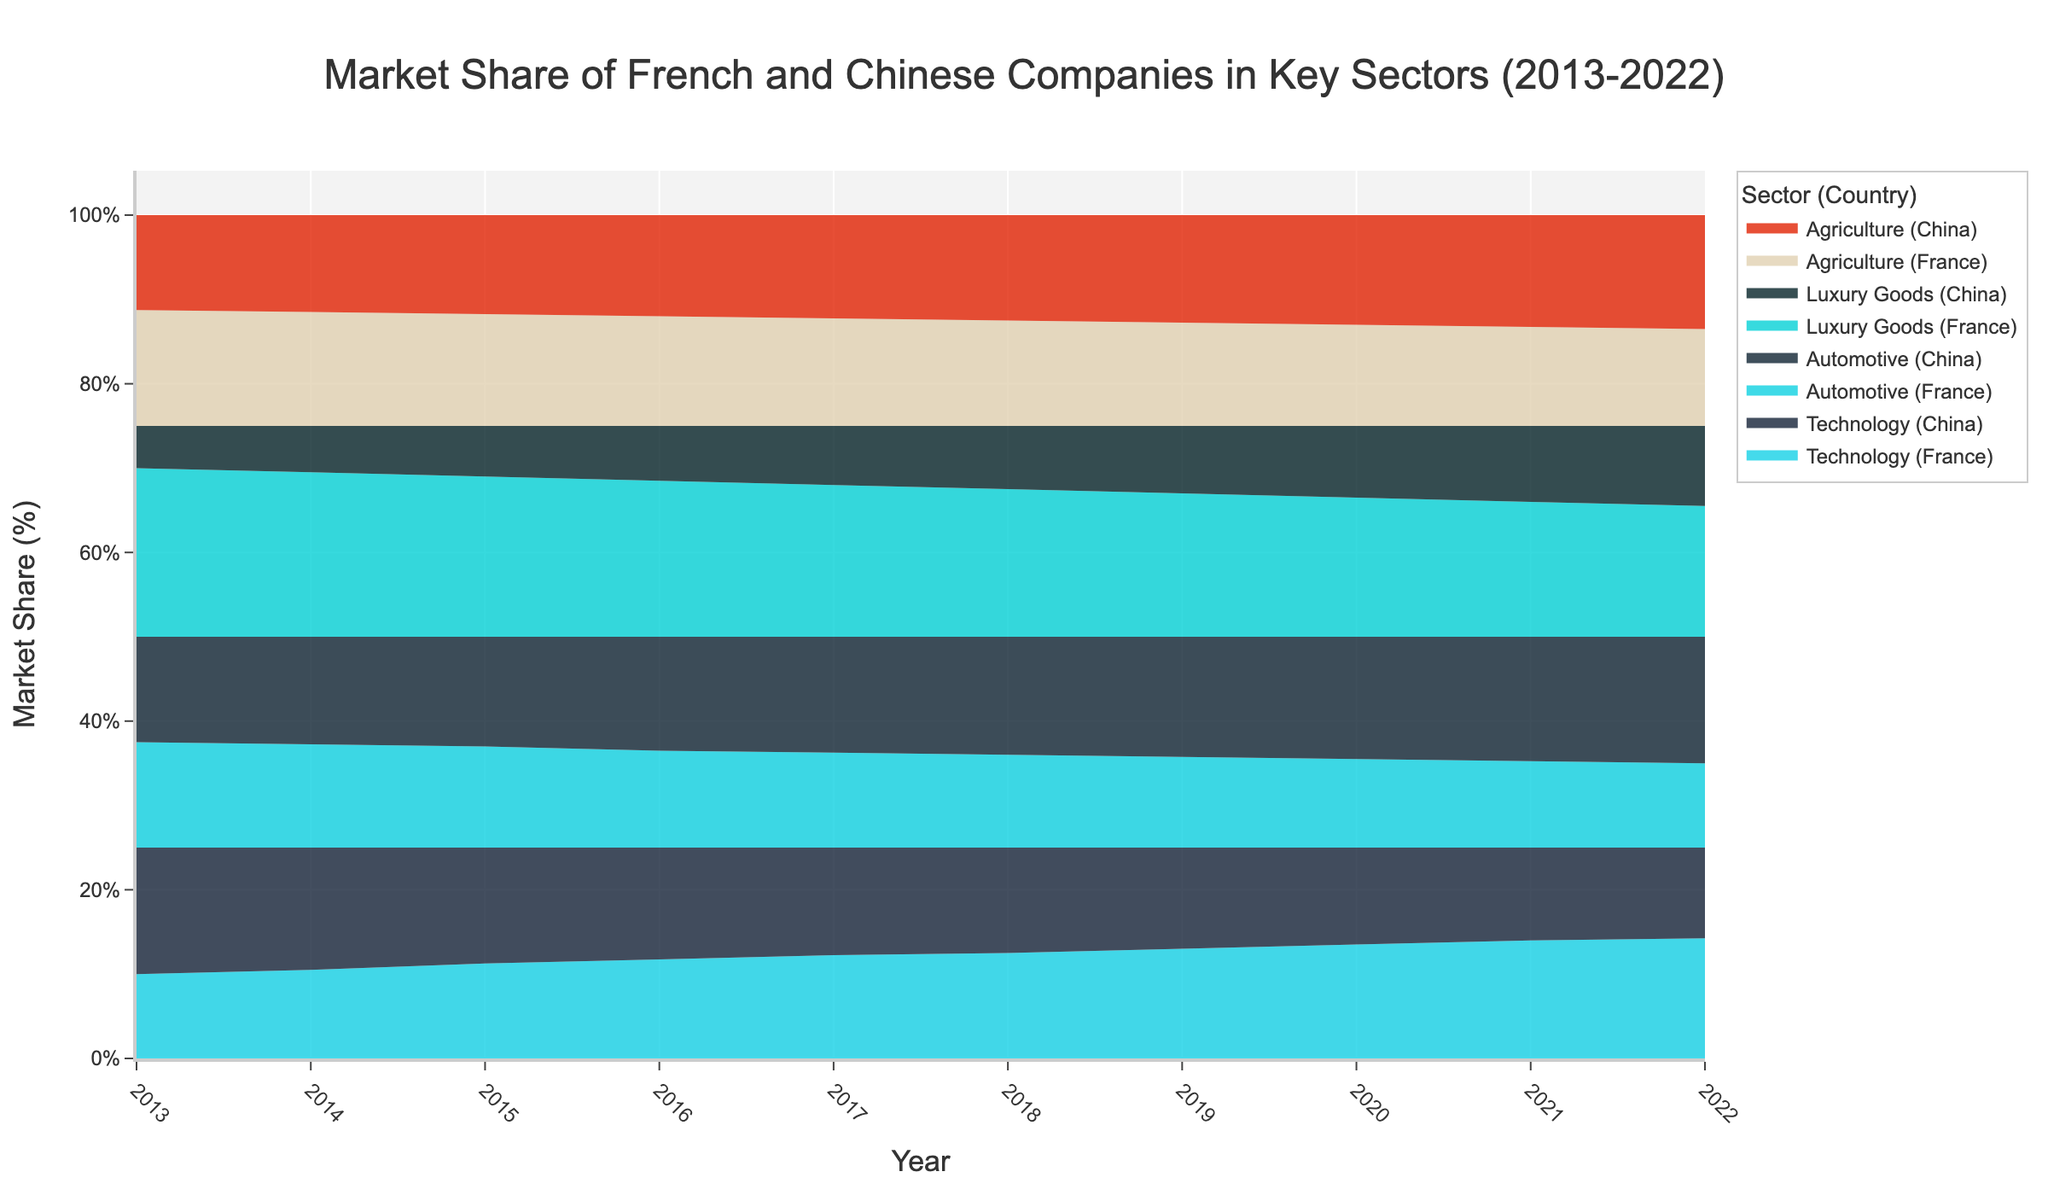What is the title of the chart? The title of the chart is displayed prominently at the top and directly indicates the figure's focus. The title reads "Market Share of French and Chinese Companies in Key Sectors (2013-2022)"
Answer: Market Share of French and Chinese Companies in Key Sectors (2013-2022) Which sector shows a continuous decrease in the French market share from 2013 to 2022? By observing the trend lines from 2013 to 2022, the French share in the Automotive sector consistently decreases over the years.
Answer: Automotive How did the market share of Chinese companies in the Luxury Goods sector change from 2013 to 2022? The visual representation for the Luxury Goods sector related to Chinese companies shows an increase from 20% in 2013 to 38% in 2022.
Answer: Increased from 20% to 38% In which year do French and Chinese companies have an equal market share in Technology? Looking at the plotted data for Technology across the years, the two shares are equal in 2018 at 50% each.
Answer: 2018 Which country had a higher market share in Agriculture in 2019, and by how much? Observing the portion of the Agriculture sector in 2019, the Chinese market share is higher with 51%, compared to 49% for France. The difference is 2%.
Answer: China by 2% What is the total market share of French companies in Technology and Agriculture in 2015? The figure shows French market shares in Technology as 45% and Agriculture as 53% in 2015. Summing these, we get 45% + 53% = 98%.
Answer: 98% Did the market share of Chinese companies in the Automotive sector ever surpass the market share of French companies in Technology? If so, when? The chart shows that from 2016 onwards, the Chinese market share in Automotive (54% in 2016) surpasses the French market share in Technology, which in 2016 is 47%.
Answer: Yes, from 2016 onwards From 2013 to 2022, which sector experienced the most stable market share for French companies? By examining the changes in market share for all sectors, the Agriculture sector shows minimal variation, maintaining a steady range of around 55% to 46% for French companies across the years.
Answer: Agriculture How much did the market share of French companies in the Luxury Goods sector decrease from 2013 to 2022? The chart indicates a decrease from 80% in 2013 to 62% in 2022, which calculates as 80% - 62% = 18%.
Answer: 18% Which sector shows nearly equal market shares for French and Chinese companies in 2020? Observing the data for 2020, Agriculture shows nearly equal market shares, with French companies at 48% and Chinese companies at 52%.
Answer: Agriculture 